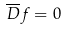<formula> <loc_0><loc_0><loc_500><loc_500>\overline { D } f = 0</formula> 